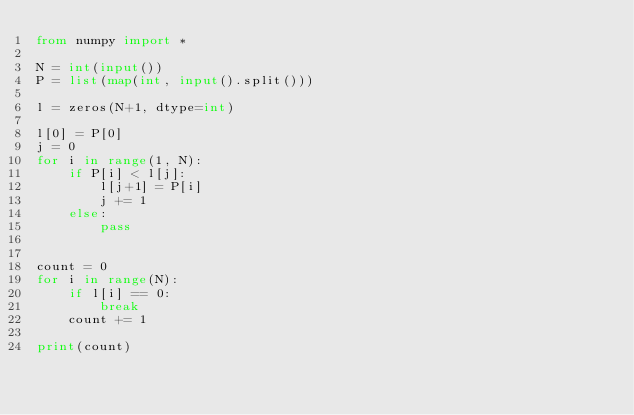<code> <loc_0><loc_0><loc_500><loc_500><_Python_>from numpy import *

N = int(input())
P = list(map(int, input().split()))

l = zeros(N+1, dtype=int)

l[0] = P[0]
j = 0
for i in range(1, N):
    if P[i] < l[j]:
        l[j+1] = P[i]
        j += 1
    else:
        pass


count = 0
for i in range(N):
    if l[i] == 0:
        break
    count += 1

print(count)
</code> 